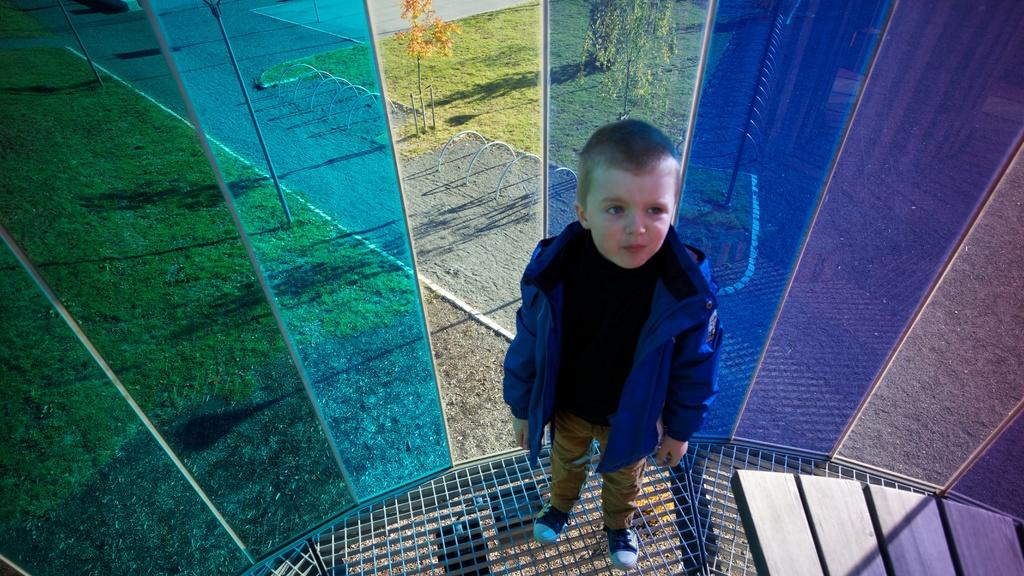What is the main subject of the image? There is a boy standing in the image. What is the boy wearing? The boy is wearing a coat, trousers, and shoes. What can be seen in the middle of the image? There are glasses in the middle of the image. What type of vegetation is visible at the back side of the image? There are trees at the back side of the image. What type of disgust can be seen on the boy's face in the image? There is no indication of disgust on the boy's face in the image. Can you tell me how many hooks are attached to the boy's coat? There are no hooks visible on the boy's coat in the image. 